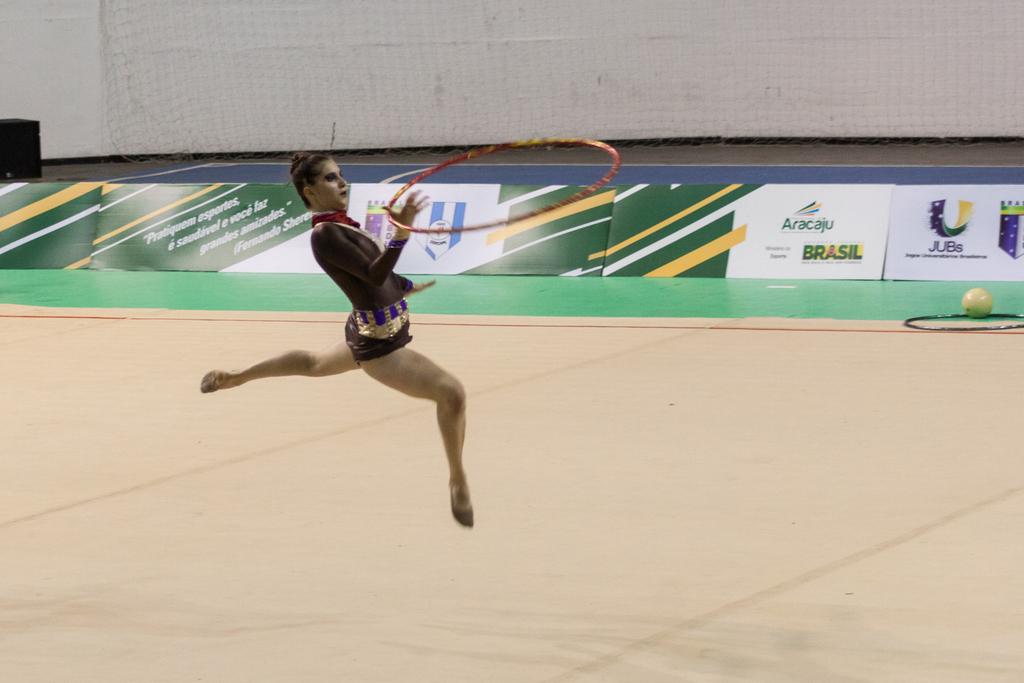What is one of the companies on the walls?
Your response must be concise. Aracaju. What country is listed on the advertisement board?
Your answer should be compact. Brasil. 